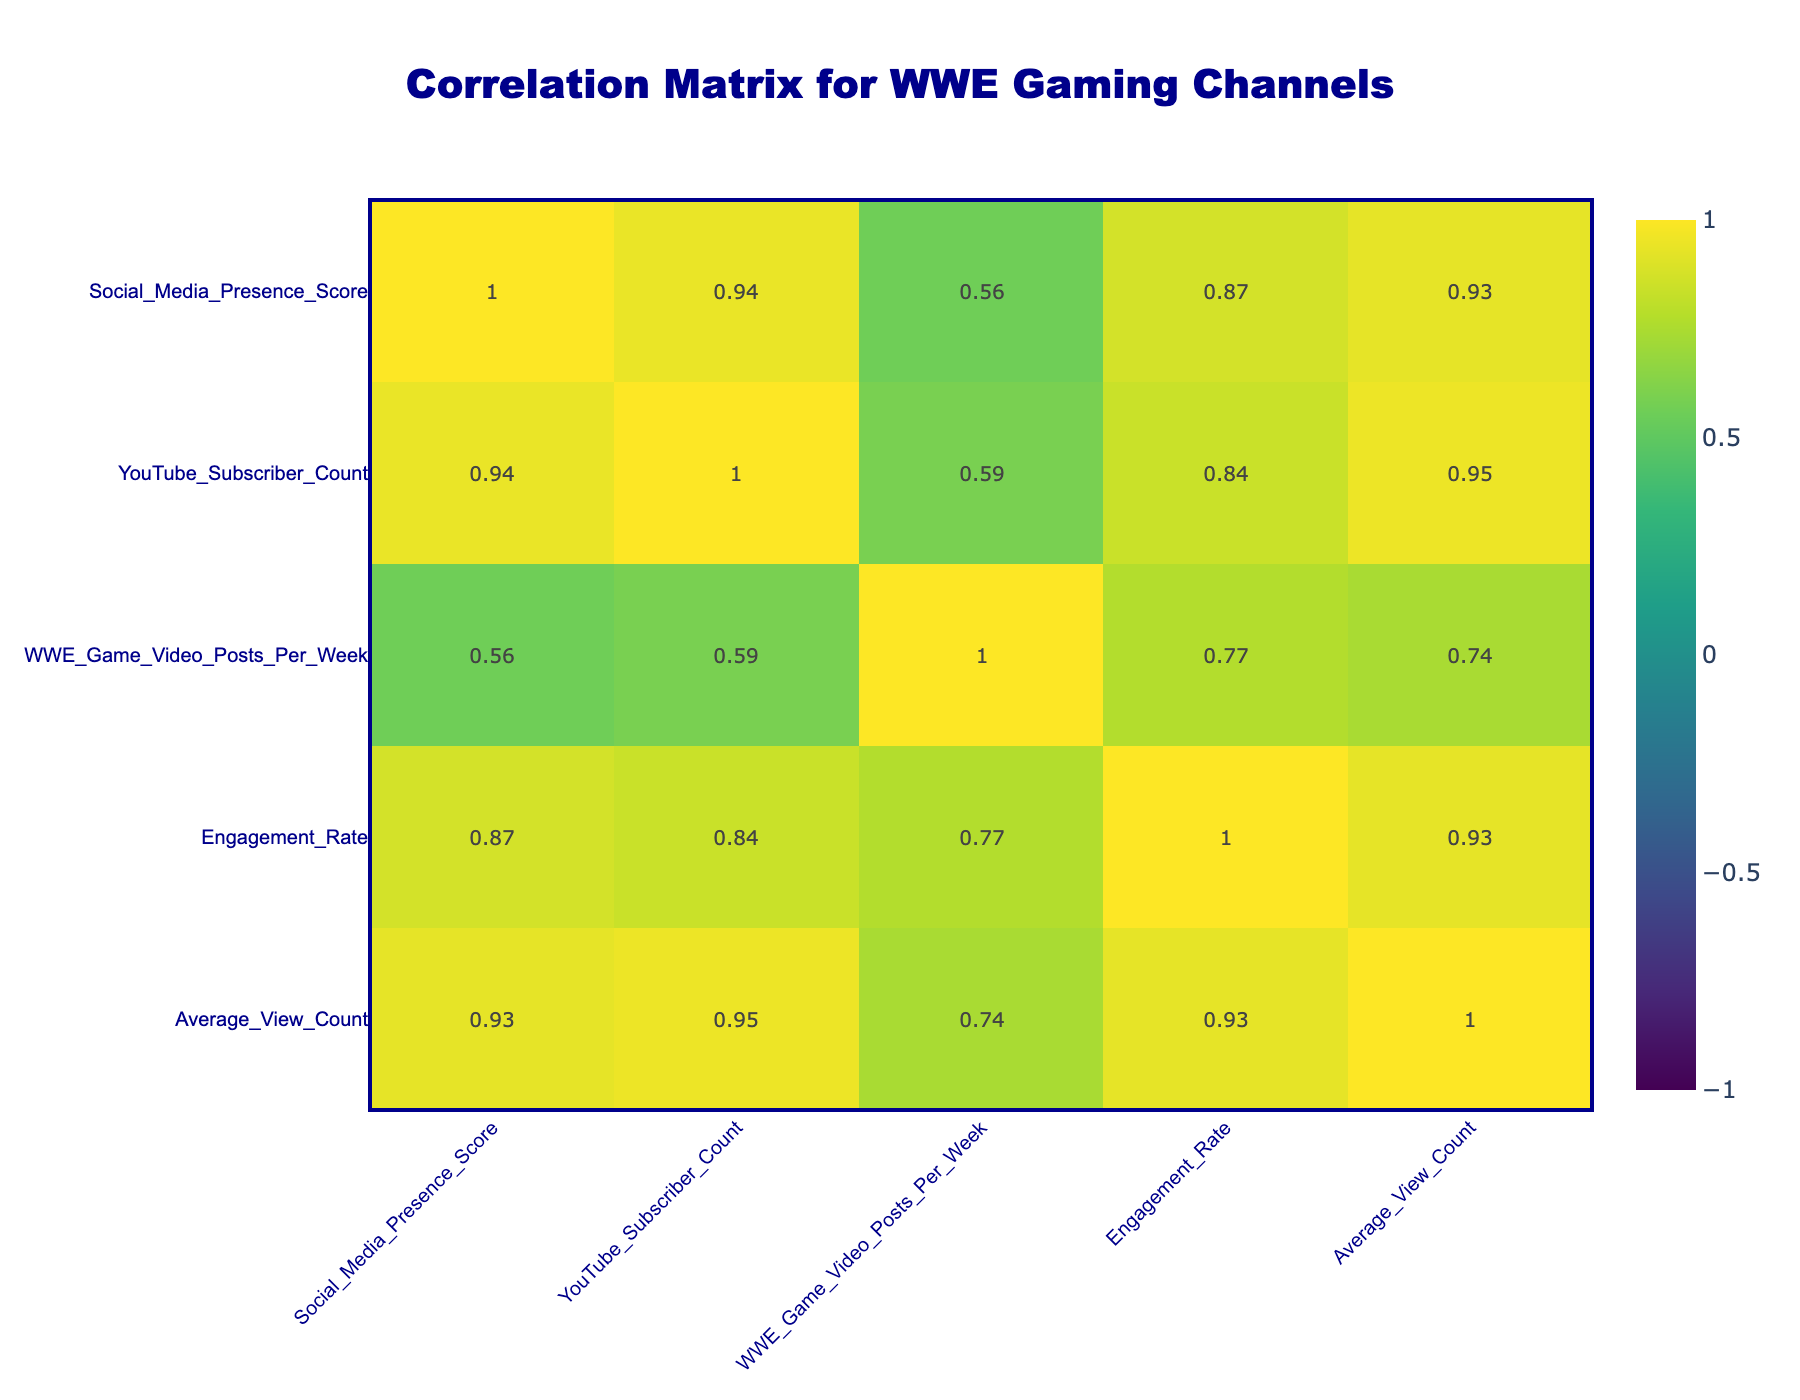What is the highest Social Media Presence Score among the channels? The table lists the Social Media Presence Scores for each channel. By examining the scores, "GamerBroWWE" has the highest score of 90.
Answer: 90 Which channel has the lowest YouTube Subscriber Count? Looking through the YouTube Subscriber Count for all channels, "KingOfTheRingYT" has the lowest count at 150,000.
Answer: 150000 What is the average Engagement Rate of the channels? The Engagement Rates are 7.5, 5.0, 4.5, 8.0, 6.0, 3.5, 7.0, 6.5, 4.0, and 8.5. Summing these together gives 54, dividing by the number of channels (10), results in 5.4.
Answer: 5.4 Is there a correlation between Social Media Presence Score and YouTube Subscriber Count? To determine correlation, we must examine the respective scores: higher Social Media Presence Scores generally correspond to higher Subscriber Counts. For instance, as the Social Media Presence increases, the Subscriber Count trends upward, suggesting a positive correlation.
Answer: Yes What is the difference in Average View Count between "GrappleGaming" and "SlamMasterMike"? The Average View Count for "GrappleGaming" is 175,000, while for "SlamMasterMike" it is 60,000. The difference is 175,000 - 60,000 = 115,000.
Answer: 115000 Which channel posts more WWE Game Videos per week than the average of 3? Channels with posts above 3 per week include "GamerBroWWE" (5), "SlamMasterMike" (4), "EpicWWEFights" (4), and "GrappleGaming" (5). Hence, there are four channels meeting this criterion.
Answer: 4 What is the combination of Engagement Rate and Social Media Presence Score for "WWEUniverseReviews"? For "WWEUniverseReviews," the Engagement Rate is 6.0 and the Social Media Presence Score is 75. Combining these metrics involves summarizing them as a tuple: (6.0, 75).
Answer: (6.0, 75) Does any channel have a Subscriber Count greater than its Social Media Presence Score when both are treated as integers? When treated as integers, "GamerBroWWE" has 750,000 subscribers against a score of 90, which does exceed its presence score. Checking others shows that "WrestleManiaGaming" and "GrappleGaming" also have counts exceeding their scores.
Answer: Yes What is the average Subscriber Count of the top three channels by Social Media Presence Score? The top three channels by Social Media Presence Score are "GamerBroWWE" (750,000), "GrappleGaming" (550,000), and "WrestleManiaGaming" (500,000). Summing these gives 1,850,000, and dividing by 3 gives an average of 616,667.
Answer: 616667 